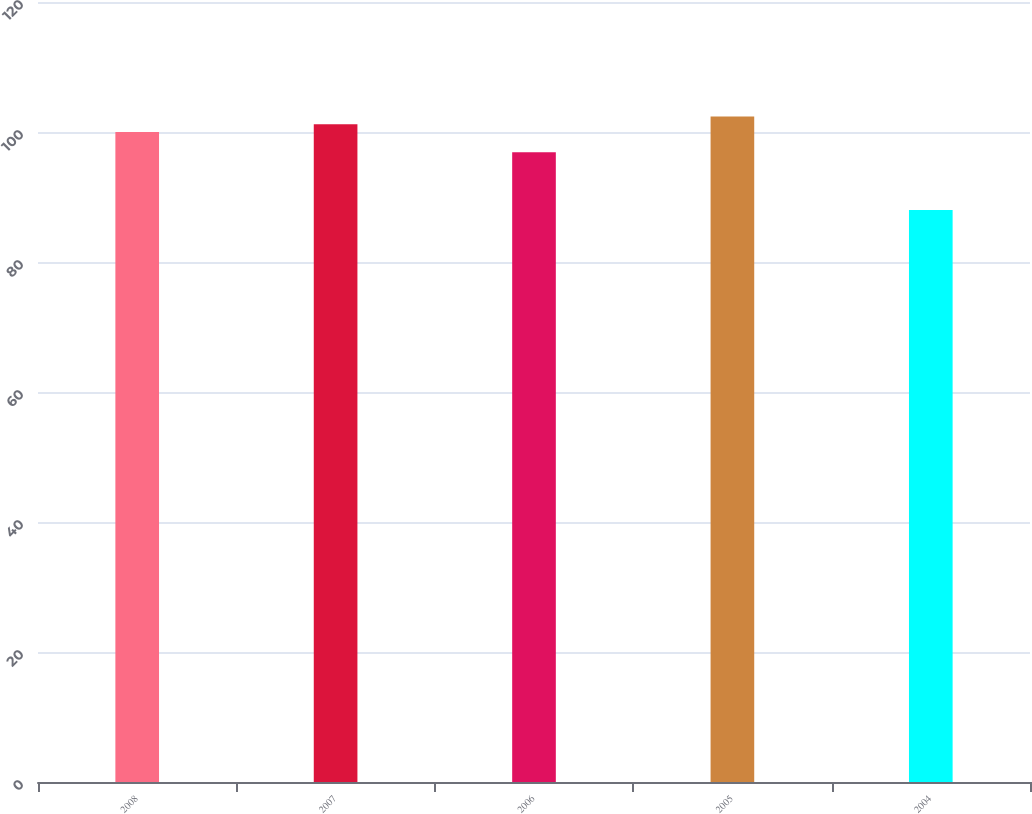Convert chart to OTSL. <chart><loc_0><loc_0><loc_500><loc_500><bar_chart><fcel>2008<fcel>2007<fcel>2006<fcel>2005<fcel>2004<nl><fcel>100<fcel>101.2<fcel>96.9<fcel>102.4<fcel>88<nl></chart> 